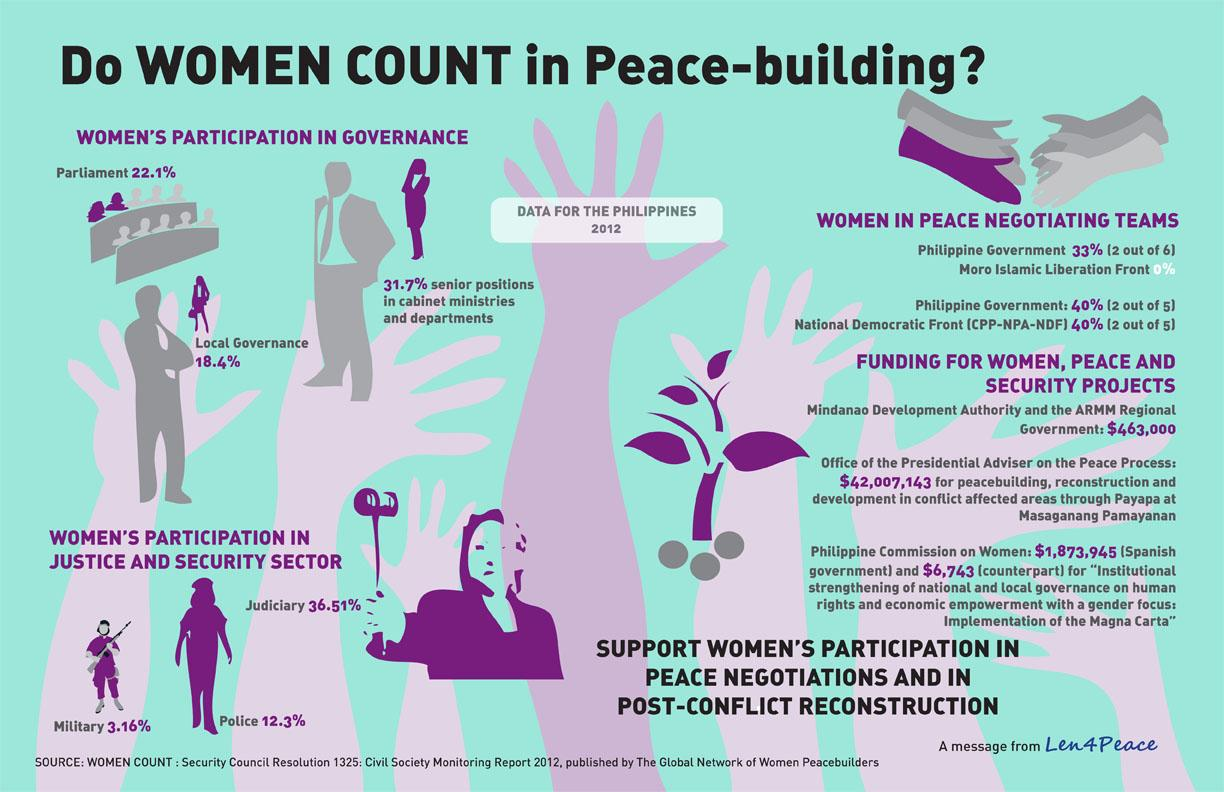Give some essential details in this illustration. According to the Civil Society Monitoring Report 2012, only 31.7% of women held senior positions in cabinet ministries and departments in the Philippines. According to the Civil Society Monitoring Report 2012, only 12.3% of women were represented in the Philippines police services. According to the Civil Society Monitoring Report 2012, only 22.1% of women were represented in the parliament of the Philippines. According to the Civil Society Monitoring Report 2012, only 3.16% of women serve in the military services of the Philippines. 